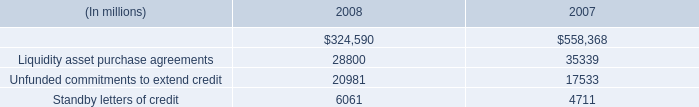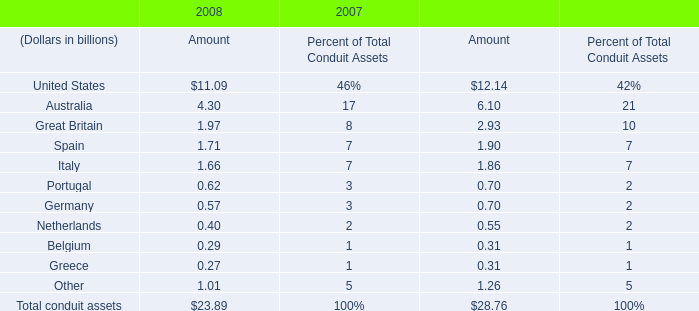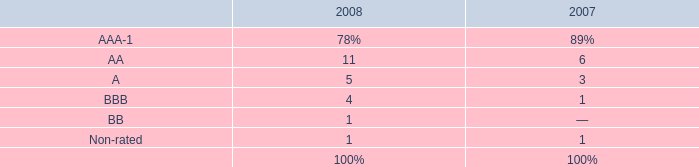what portion of the 2008 collateral was invested in indemnified repurchase agreements in 2008? 
Computations: (68.37 / 333.07)
Answer: 0.20527. 